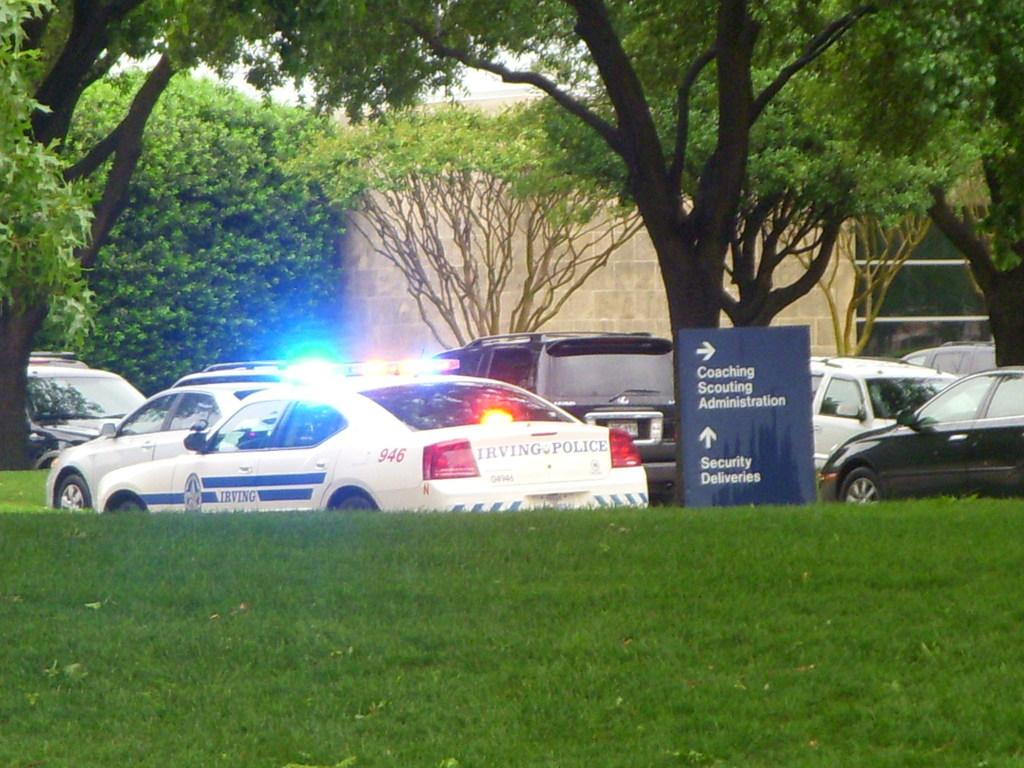What type of vegetation is at the bottom of the image? There is grass at the bottom of the image. What vehicles are visible in the image? There are cars in the center of the image. What can be seen in the background of the image? There are trees and a wall in the background of the image. What type of can is being used to fulfill the purpose of the wood in the image? There is no can or wood present in the image. 